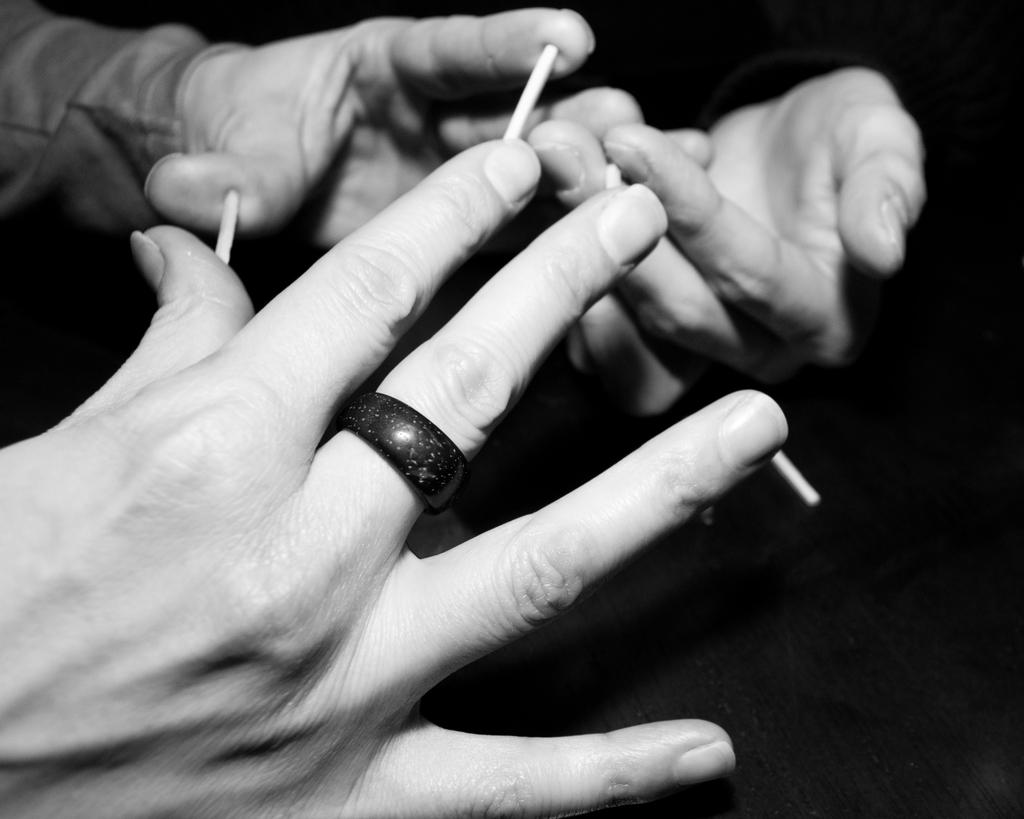What is being held by the people's hands in the image? There are people's hands holding sticks in the image. Can you describe the position or action of the hands in the image? The hands are holding the sticks, but the specific position or action cannot be determined from the provided facts. What type of road can be seen in the image? There is no road present in the image; it only shows people's hands holding sticks. 